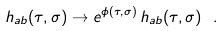Convert formula to latex. <formula><loc_0><loc_0><loc_500><loc_500>h _ { a b } ( \tau , \sigma ) \rightarrow e ^ { \phi ( \tau , \sigma ) } \, h _ { a b } ( \tau , \sigma ) \ .</formula> 